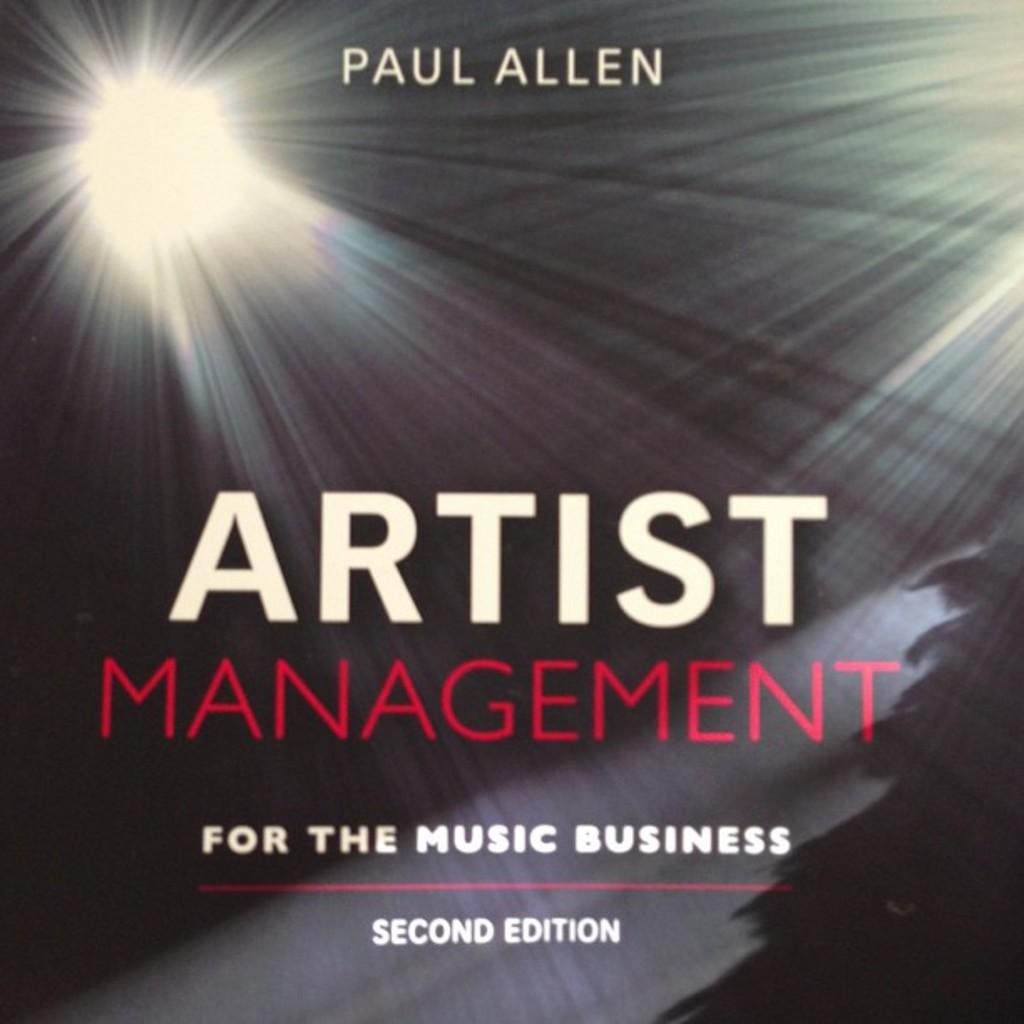What edition is this book?
Your answer should be compact. Second. Who wrote is book?
Your answer should be very brief. Paul allen. 